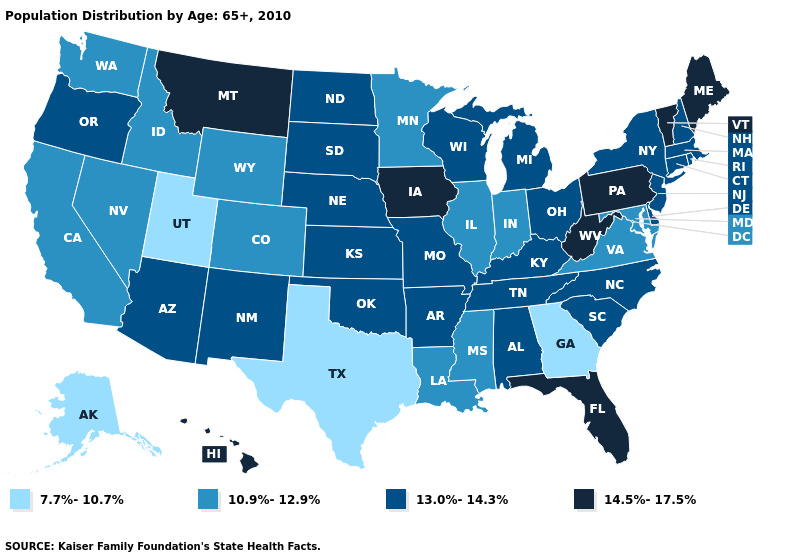Name the states that have a value in the range 13.0%-14.3%?
Quick response, please. Alabama, Arizona, Arkansas, Connecticut, Delaware, Kansas, Kentucky, Massachusetts, Michigan, Missouri, Nebraska, New Hampshire, New Jersey, New Mexico, New York, North Carolina, North Dakota, Ohio, Oklahoma, Oregon, Rhode Island, South Carolina, South Dakota, Tennessee, Wisconsin. Is the legend a continuous bar?
Give a very brief answer. No. Does Wisconsin have the highest value in the MidWest?
Be succinct. No. Does Virginia have the highest value in the South?
Quick response, please. No. How many symbols are there in the legend?
Answer briefly. 4. What is the value of Alaska?
Give a very brief answer. 7.7%-10.7%. Does the first symbol in the legend represent the smallest category?
Be succinct. Yes. What is the highest value in the USA?
Answer briefly. 14.5%-17.5%. Name the states that have a value in the range 10.9%-12.9%?
Quick response, please. California, Colorado, Idaho, Illinois, Indiana, Louisiana, Maryland, Minnesota, Mississippi, Nevada, Virginia, Washington, Wyoming. Name the states that have a value in the range 10.9%-12.9%?
Keep it brief. California, Colorado, Idaho, Illinois, Indiana, Louisiana, Maryland, Minnesota, Mississippi, Nevada, Virginia, Washington, Wyoming. Does the first symbol in the legend represent the smallest category?
Be succinct. Yes. Name the states that have a value in the range 10.9%-12.9%?
Keep it brief. California, Colorado, Idaho, Illinois, Indiana, Louisiana, Maryland, Minnesota, Mississippi, Nevada, Virginia, Washington, Wyoming. Does the map have missing data?
Keep it brief. No. How many symbols are there in the legend?
Concise answer only. 4. Does the map have missing data?
Quick response, please. No. 